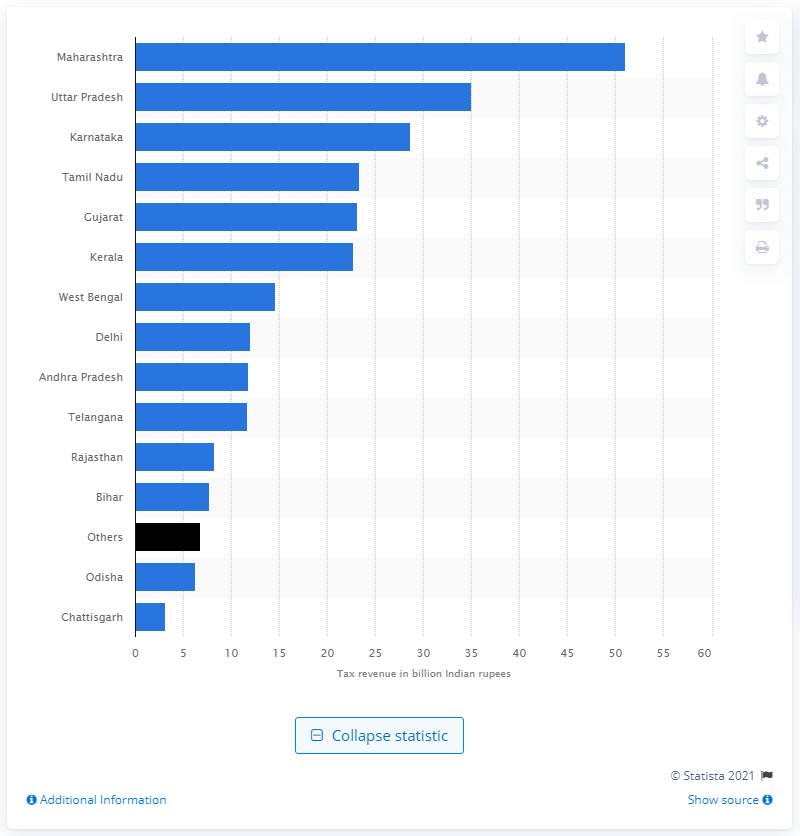Give some essential details in this illustration. The motor vehicle tax revenue in Maharashtra for the fiscal year 2016 was 51.07 Indian rupees. 